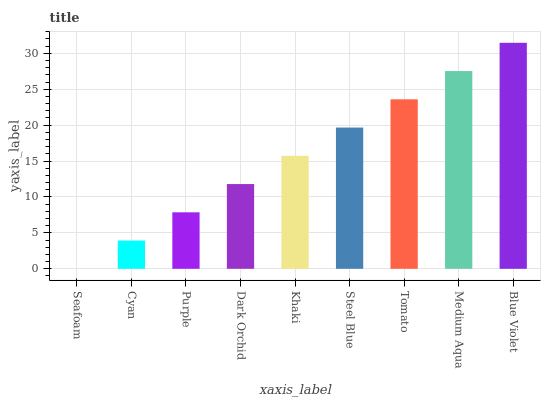Is Seafoam the minimum?
Answer yes or no. Yes. Is Blue Violet the maximum?
Answer yes or no. Yes. Is Cyan the minimum?
Answer yes or no. No. Is Cyan the maximum?
Answer yes or no. No. Is Cyan greater than Seafoam?
Answer yes or no. Yes. Is Seafoam less than Cyan?
Answer yes or no. Yes. Is Seafoam greater than Cyan?
Answer yes or no. No. Is Cyan less than Seafoam?
Answer yes or no. No. Is Khaki the high median?
Answer yes or no. Yes. Is Khaki the low median?
Answer yes or no. Yes. Is Steel Blue the high median?
Answer yes or no. No. Is Blue Violet the low median?
Answer yes or no. No. 